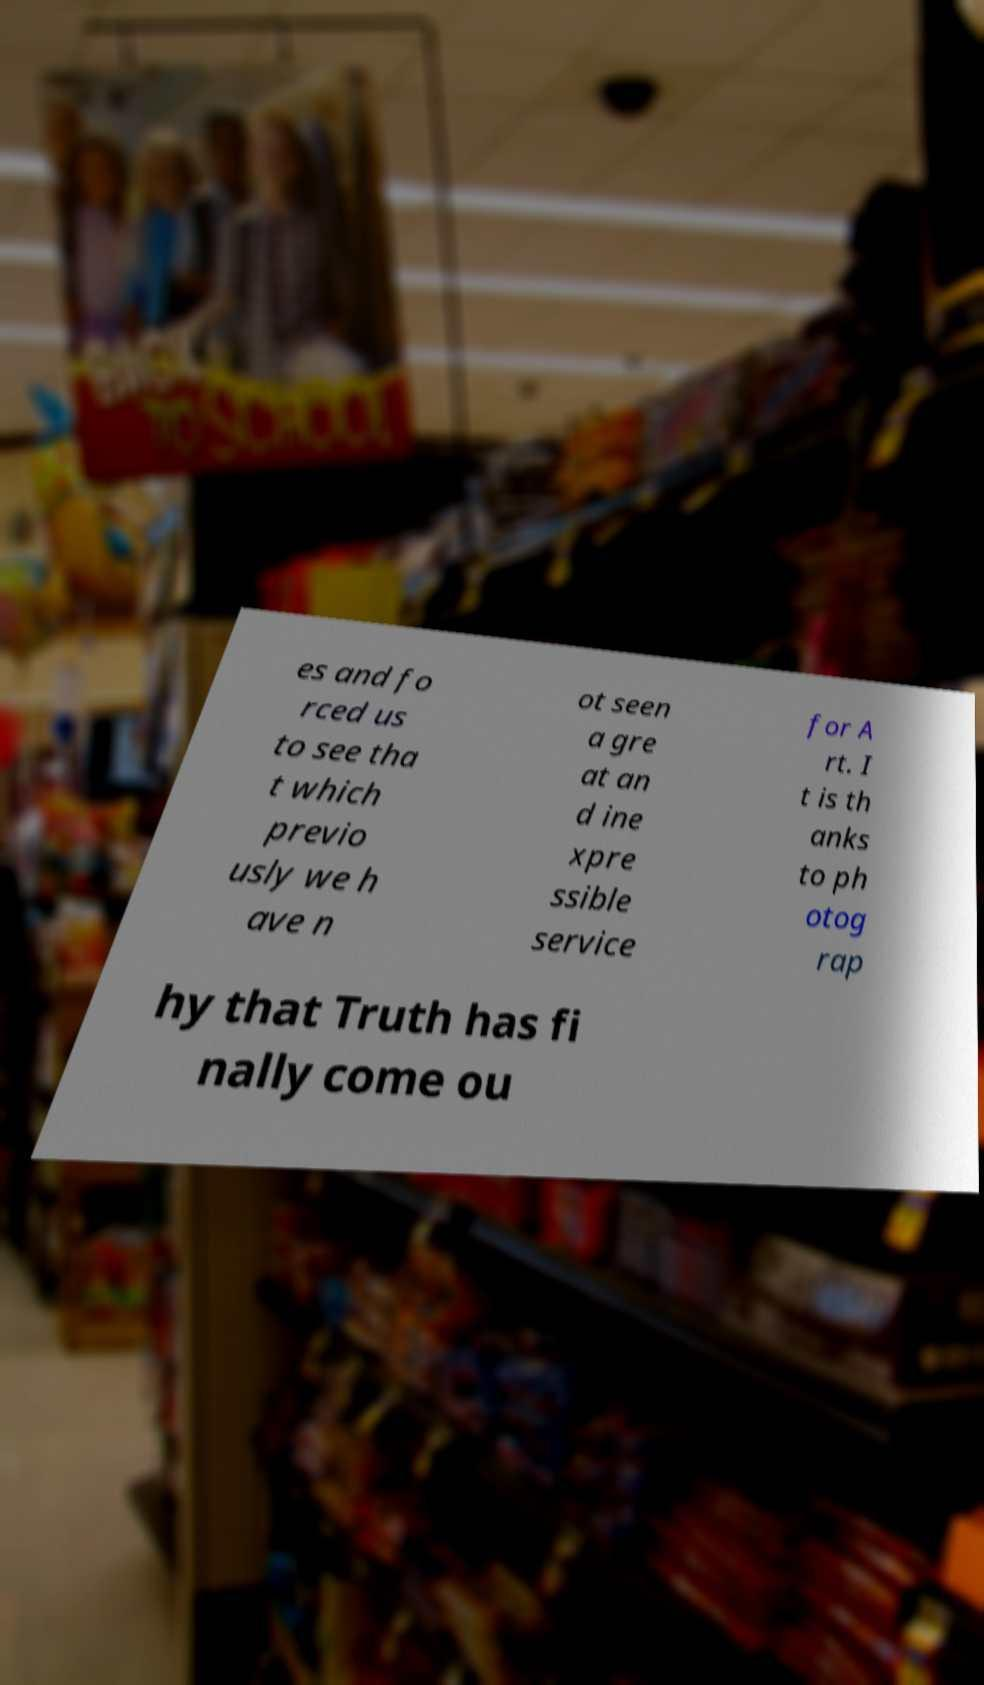For documentation purposes, I need the text within this image transcribed. Could you provide that? es and fo rced us to see tha t which previo usly we h ave n ot seen a gre at an d ine xpre ssible service for A rt. I t is th anks to ph otog rap hy that Truth has fi nally come ou 